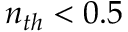<formula> <loc_0><loc_0><loc_500><loc_500>n _ { t h } < 0 . 5</formula> 